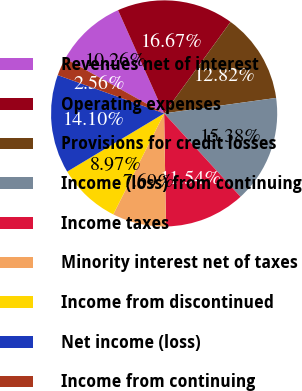Convert chart to OTSL. <chart><loc_0><loc_0><loc_500><loc_500><pie_chart><fcel>Revenues net of interest<fcel>Operating expenses<fcel>Provisions for credit losses<fcel>Income (loss) from continuing<fcel>Income taxes<fcel>Minority interest net of taxes<fcel>Income from discontinued<fcel>Net income (loss)<fcel>Income from continuing<nl><fcel>10.26%<fcel>16.67%<fcel>12.82%<fcel>15.38%<fcel>11.54%<fcel>7.69%<fcel>8.97%<fcel>14.1%<fcel>2.56%<nl></chart> 